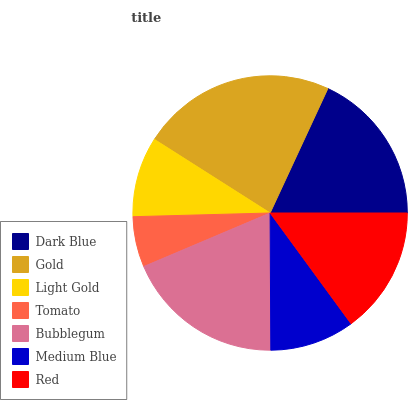Is Tomato the minimum?
Answer yes or no. Yes. Is Gold the maximum?
Answer yes or no. Yes. Is Light Gold the minimum?
Answer yes or no. No. Is Light Gold the maximum?
Answer yes or no. No. Is Gold greater than Light Gold?
Answer yes or no. Yes. Is Light Gold less than Gold?
Answer yes or no. Yes. Is Light Gold greater than Gold?
Answer yes or no. No. Is Gold less than Light Gold?
Answer yes or no. No. Is Red the high median?
Answer yes or no. Yes. Is Red the low median?
Answer yes or no. Yes. Is Bubblegum the high median?
Answer yes or no. No. Is Bubblegum the low median?
Answer yes or no. No. 